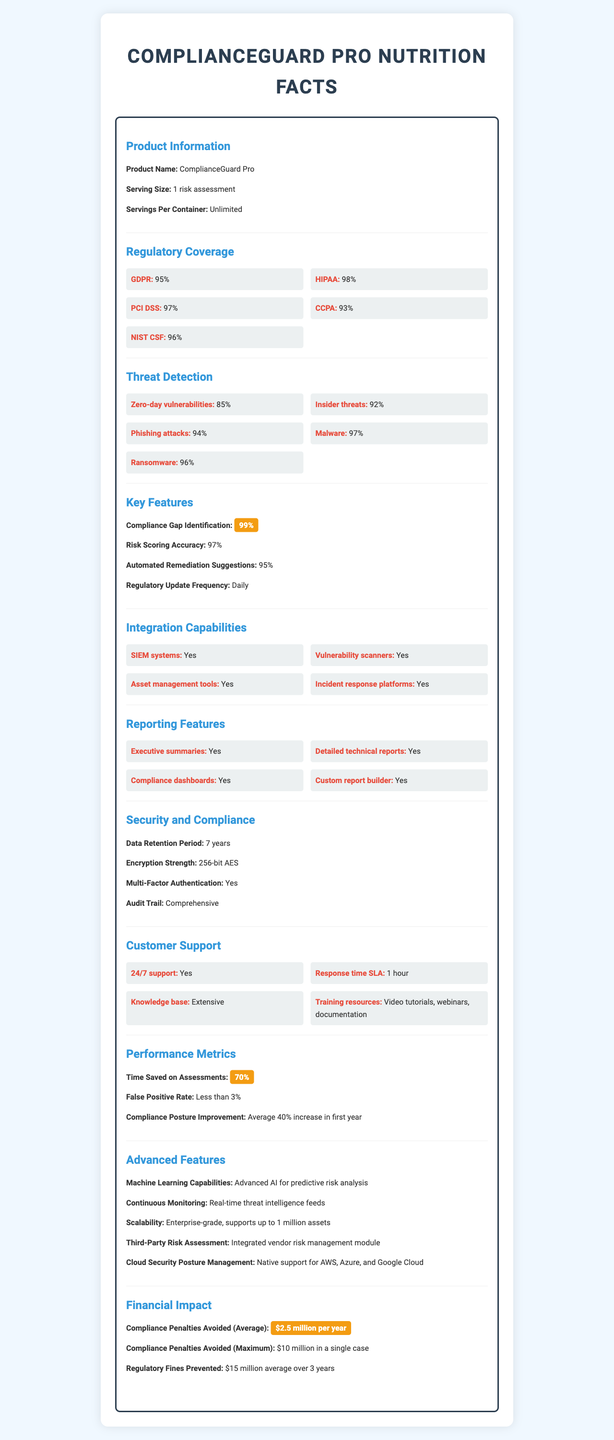what is the product name? The product name is found at the top of the document under the section "Product Information," labelled as "Product Name."
Answer: ComplianceGuard Pro what is the serving size? The serving size is listed in the "Product Information" section and is specified as "1 risk assessment."
Answer: 1 risk assessment how often is the regulatory update frequency? The regulatory update frequency is mentioned in the "Key Features" section and is indicated as "Daily."
Answer: Daily what encryption strength is used? The encryption strength is defined in the "Security and Compliance" section as "256-bit AES."
Answer: 256-bit AES how many assets can ComplianceGuard Pro support? The scalability feature in the "Advanced Features" section specifies that it supports up to 1 million assets.
Answer: Up to 1 million assets which regulatory framework is covered the least by ComplianceGuard Pro? A. GDPR B. HIPAA C. CCPA D. PCI DSS The "Regulatory Coverage" section lists CCPA with a coverage of 93%, which is the lowest among the frameworks listed.
Answer: C. CCPA what support options are available for customer support? A. 24/7 support B. Response time SLA of 1 hour C. Extensive Knowledge base D. Training resources E. All of the above In the "Customer Support" section, all these options are listed as part of the support provided.
Answer: E. All of the above is the third-party risk assessment feature included? The advanced features section mentions that there is an "Integrated vendor risk management module" for third-party risk assessment.
Answer: Yes can ComplianceGuard Pro detect insider threats? The "Threat Detection" section lists "Insider threats" with a detection rate of 92%.
Answer: Yes what is the data retention period? The data retention period can be found in the "Security and Compliance" section and is listed as "7 years."
Answer: 7 years how much time does ComplianceGuard Pro save on assessments? It is mentioned in the "Performance Metrics" section that the time saved on assessments is "70%."
Answer: 70% what is the compliance gap identification rate? The key feature of "Compliance Gap Identification" in the "Key Features" section specifies it has a 99% identification rate.
Answer: 99% summarize the main idea of the document. This document serves as a comprehensive overview of ComplianceGuard Pro, detailing all aspects of its functionality, support, and benefits to help users understand its capabilities and effectiveness in compliance and risk management.
Answer: The document provides detailed information about ComplianceGuard Pro, highlighting its capabilities in regulatory coverage, threat detection, key features, integration capabilities, reporting features, security and compliance, customer support, performance metrics, advanced features, and financial impact. how much in regulatory fines has ComplianceGuard Pro prevented on average over three years? The "Financial Impact" section indicates regulatory fines prevented are $15 million on average over three years.
Answer: $15 million what is the maximum compliance penalty avoided by ComplianceGuard Pro in a single case? According to the "Financial Impact" section, the maximum compliance penalty avoided in a single case is $10 million.
Answer: $10 million which user access level has full control? The "User Access Levels" section lists that the Admin has "Full control."
Answer: Admin what technology readiness for encryption does ComplianceGuard Pro have? The "Advanced Features" section specifies that ComplianceGuard Pro is "Prepared for post-quantum cryptography."
Answer: Quantum-Safe Encryption Readiness what is the false positive rate? The "Performance Metrics" section lists the false positive rate as "Less than 3%."
Answer: Less than 3% does ComplianceGuard Pro support mobile apps? The "Advanced Features" section indicates that there is mobile app availability for iOS and Android.
Answer: Yes what is the average compliance penalties avoided annually? The "Financial Impact" section specifies that the average compliance penalties avoided annually are "$2.5 million per year."
Answer: $2.5 million per year does ComplianceGuard Pro integrate with blockchain technologies? The "Advanced Features" section mentions "Blockchain Integration" with "Smart contract auditing capabilities."
Answer: Yes what is the response time SLA for customer support? The "Customer Support" section specifies a response time SLA of "1 hour."
Answer: 1 hour how does ComplianceGuard Pro help with cyber insurance? The "Advanced Features" section mentions that it provides "Automated policy recommendations" for cyber insurance.
Answer: Automated policy recommendations describe the integration capabilities of ComplianceGuard Pro. The "Integration Capabilities" section lists all these integrations explicitly.
Answer: ComplianceGuard Pro offers integration capabilities with SIEM systems, vulnerability scanners, asset management tools, and incident response platforms. what is the machine learning capability used for? The "Advanced Features" section highlights that it has "Advanced AI for predictive risk analysis."
Answer: Predictive risk analysis does the document provide details on how to configure SIEM system integrations? The document states that SIEM system integration is available but does not provide specific details on configuration.
Answer: Not enough information 